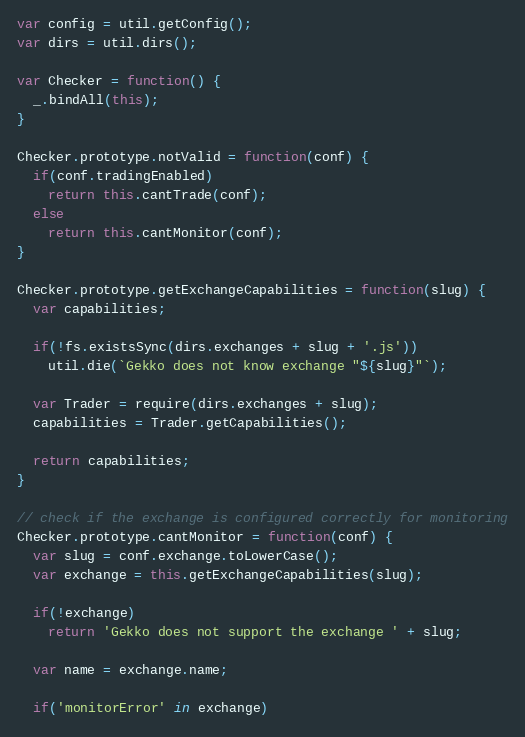<code> <loc_0><loc_0><loc_500><loc_500><_JavaScript_>var config = util.getConfig();
var dirs = util.dirs();

var Checker = function() {
  _.bindAll(this);
}

Checker.prototype.notValid = function(conf) {
  if(conf.tradingEnabled)
    return this.cantTrade(conf);
  else
    return this.cantMonitor(conf);
}

Checker.prototype.getExchangeCapabilities = function(slug) {
  var capabilities;

  if(!fs.existsSync(dirs.exchanges + slug + '.js'))
    util.die(`Gekko does not know exchange "${slug}"`);

  var Trader = require(dirs.exchanges + slug);
  capabilities = Trader.getCapabilities();

  return capabilities;
}

// check if the exchange is configured correctly for monitoring
Checker.prototype.cantMonitor = function(conf) {
  var slug = conf.exchange.toLowerCase();
  var exchange = this.getExchangeCapabilities(slug);

  if(!exchange)
    return 'Gekko does not support the exchange ' + slug;

  var name = exchange.name;

  if('monitorError' in exchange)</code> 